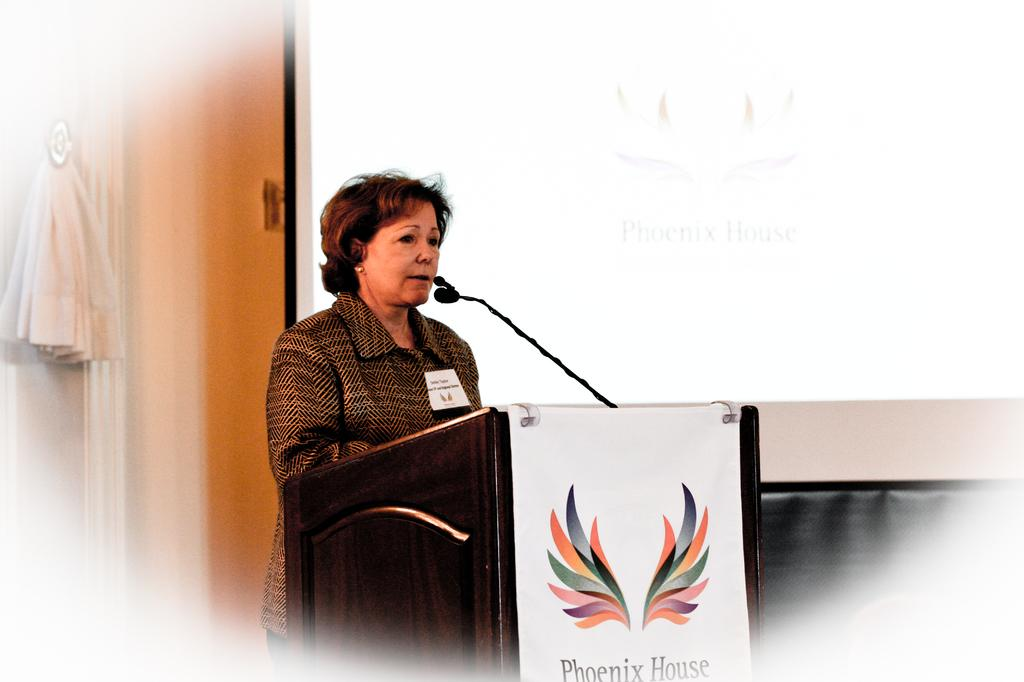Who is present in the image? There is a woman in the image. What is the woman doing in the image? The woman is standing and speaking in the image. What object is present to amplify her voice? There is a microphone in the image, placed on a wooden stand. Where is the woman positioned in relation to the microphone? The woman is in front of the microphone. What additional visual element can be seen in the image? There is a projected image in the right corner of the image. How many ducks are swimming in the harbor in the image? There are no ducks or harbor present in the image. Is the horse in the image wearing a saddle? There is no horse present in the image. 